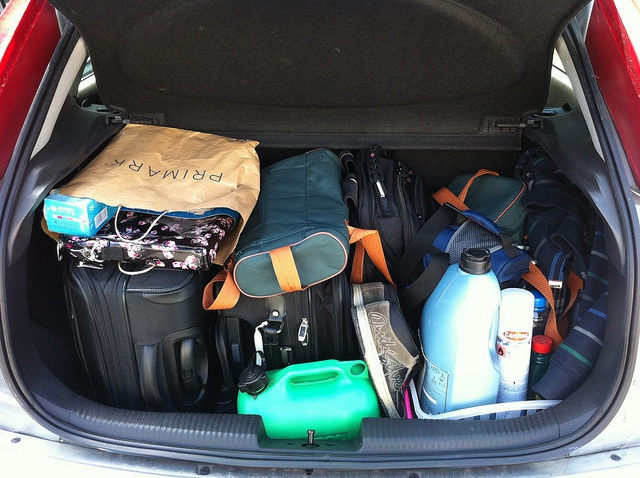Describe the objects in this image and their specific colors. I can see car in black, gray, and white tones, suitcase in black and gray tones, backpack in black, blue, gray, and teal tones, handbag in black, blue, and teal tones, and backpack in black, brown, and orange tones in this image. 